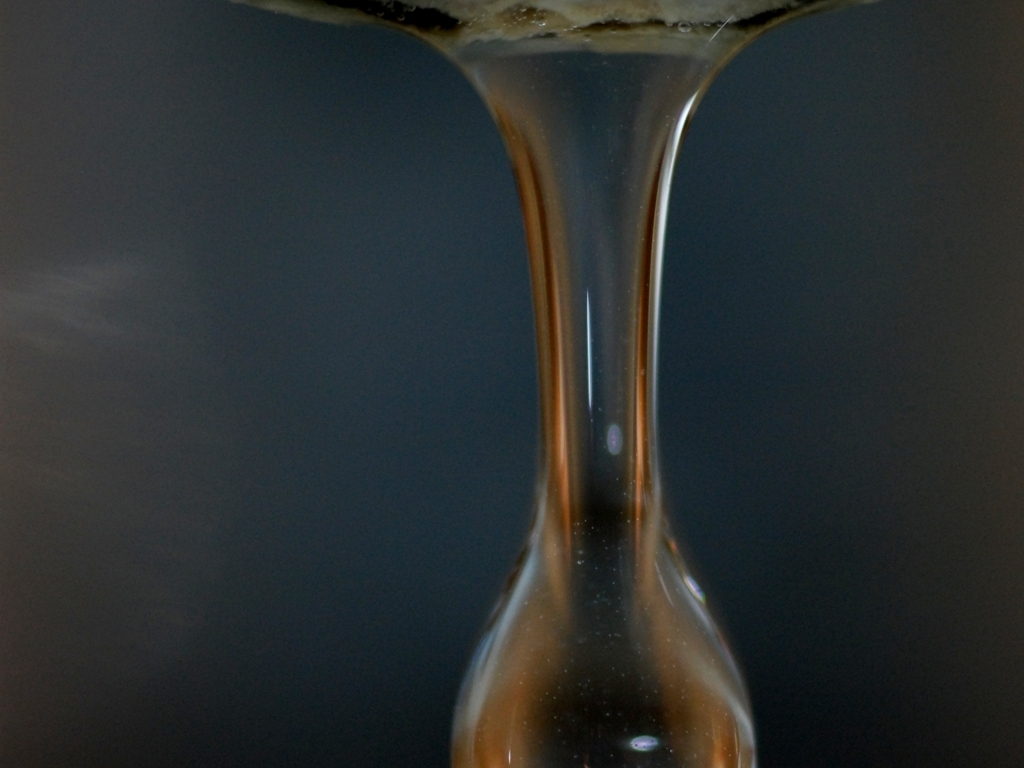Is the quality of this image poor?
A. No
B. Yes
Answer with the option's letter from the given choices directly. The image could be considered of lower quality due to noticeable blurriness and lack of sharp detail, particularly when assessing the potential for discerning fine details or textures. It seems the focus is not optimal, or a slow shutter speed may have been used, leading to a softness throughout the photo. 